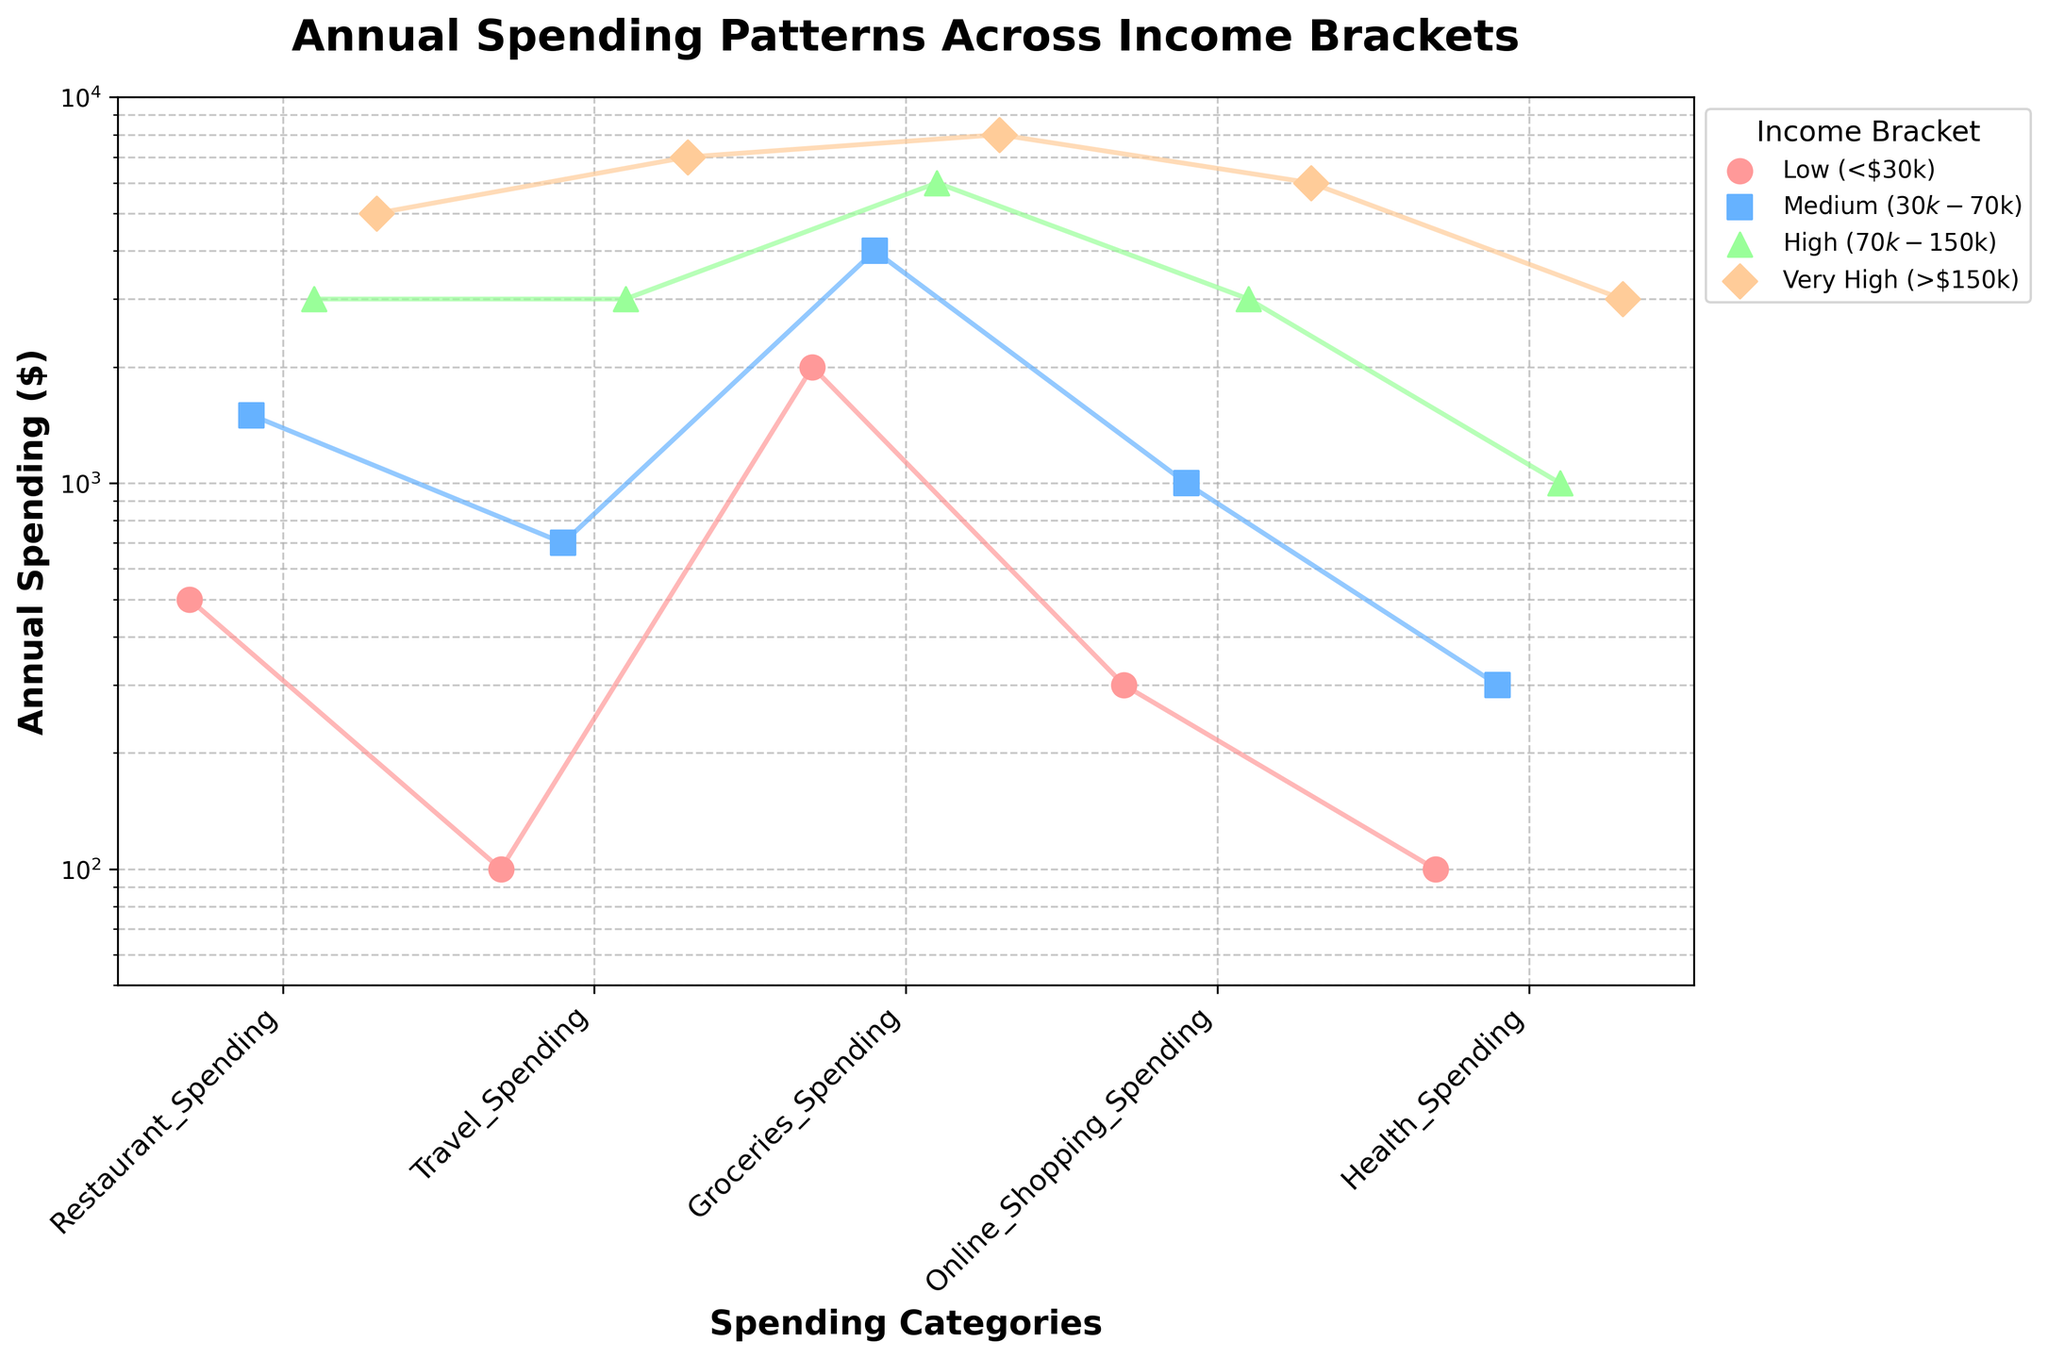What's the title of the figure? The title is displayed at the top of the figure, usually in a larger font size with bold styling for emphasis.
Answer: Annual Spending Patterns Across Income Brackets What is the spending category with the highest spending for the Low income bracket? Find the data points on the plot that correspond to the Low income bracket and identify which point is the highest. In this case, the point with the highest value is for Groceries Spending.
Answer: Groceries Spending Which spending category has the lowest median value across all income brackets? Calculate the median value for each spending category across the four income brackets. Sort the medians and identify the lowest one. Health Spending has the lowest median value.
Answer: Health Spending How does Restaurant Spending for the Very High income bracket compare to the High income bracket? Locate the data points for Restaurant Spending for both the Very High and High income brackets. Comparing the values, Very High income bracket spends more than the High income bracket.
Answer: Very High spends more What are the range of values (minimum to maximum) for Travel Spending across all income brackets? Identify the minimum and maximum values for Travel Spending among the four income levels. The minimum value is 100 and the maximum value is 7000.
Answer: 100 to 7000 Among the income brackets, which one has the highest Online Shopping Spending and what is the value? Find the data points on the plot that correspond to Online Shopping Spending and identify the highest value among them. Very High income bracket has the highest spending with 6000.
Answer: Very High, 6000 What is the trend in Health Spending as income increases from Low to Very High? Observe the data points corresponding to Health Spending across the income brackets and see if there is an increasing or decreasing pattern. Health Spending consistently increases with income.
Answer: Increases Which spending category shows the largest variance across the income brackets? Determine the spending category with the widest range of values from Low to Very High income brackets. Restaurant Spending shows the largest variance from 500 to 5000.
Answer: Restaurant Spending If you combined all the spending of each category for the Medium and High income brackets, which category has the highest combined spending? Add the spending values for each category in both Medium and High income brackets and compare the sums. Groceries Spending: 4000 + 6000 = 10000, which is the highest.
Answer: Groceries Spending What can you say about the spacing between spending values in Travel Spending with the log-scale axis? On a log scale, equal distances correspond to multiplicative differences rather than additive. Thus, the differences between low and high values of Travel Spending appear compressed compared to a linear scale. The spacing shows significant variation, compressed at high values.
Answer: Significant variation, compressed at high values 